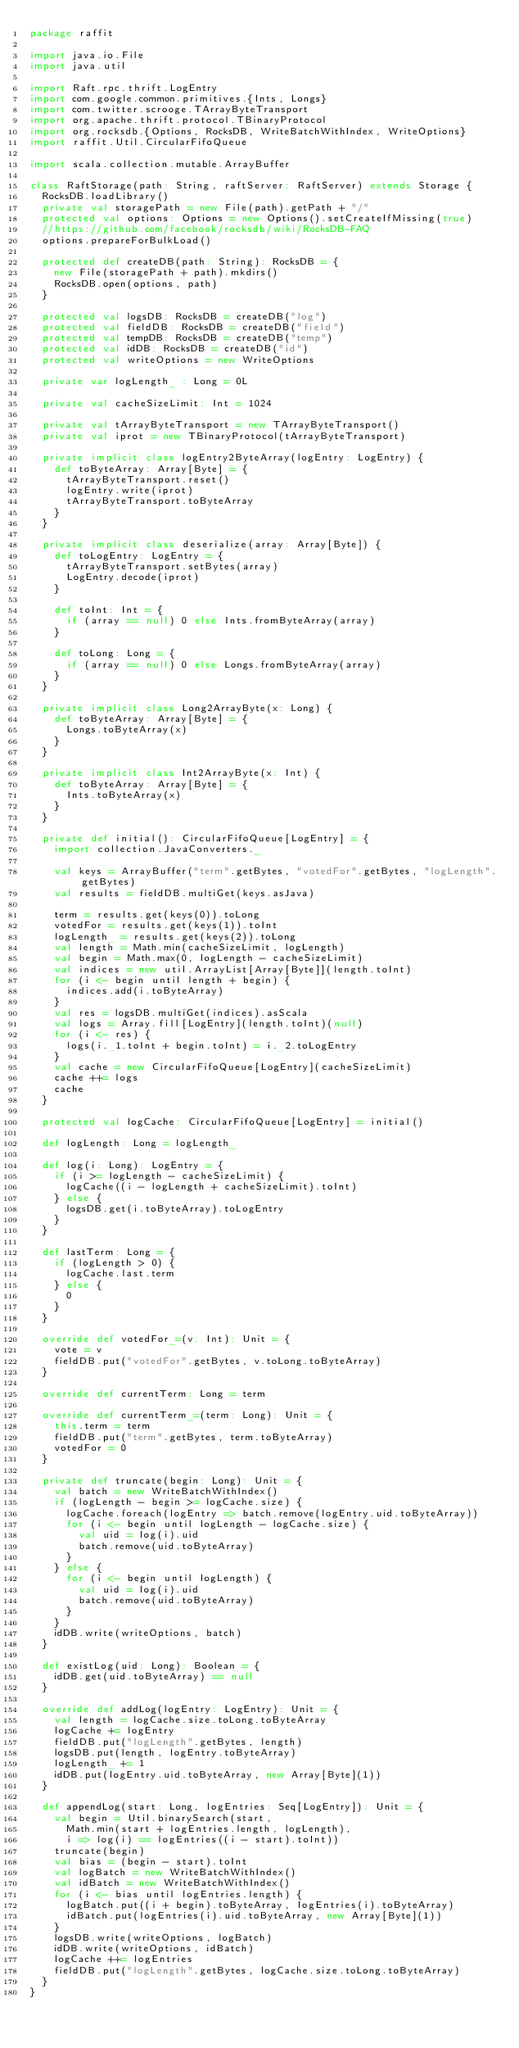Convert code to text. <code><loc_0><loc_0><loc_500><loc_500><_Scala_>package raffit

import java.io.File
import java.util

import Raft.rpc.thrift.LogEntry
import com.google.common.primitives.{Ints, Longs}
import com.twitter.scrooge.TArrayByteTransport
import org.apache.thrift.protocol.TBinaryProtocol
import org.rocksdb.{Options, RocksDB, WriteBatchWithIndex, WriteOptions}
import raffit.Util.CircularFifoQueue

import scala.collection.mutable.ArrayBuffer

class RaftStorage(path: String, raftServer: RaftServer) extends Storage {
  RocksDB.loadLibrary()
  private val storagePath = new File(path).getPath + "/"
  protected val options: Options = new Options().setCreateIfMissing(true)
  //https://github.com/facebook/rocksdb/wiki/RocksDB-FAQ
  options.prepareForBulkLoad()

  protected def createDB(path: String): RocksDB = {
    new File(storagePath + path).mkdirs()
    RocksDB.open(options, path)
  }

  protected val logsDB: RocksDB = createDB("log")
  protected val fieldDB: RocksDB = createDB("field")
  protected val tempDB: RocksDB = createDB("temp")
  protected val idDB: RocksDB = createDB("id")
  protected val writeOptions = new WriteOptions

  private var logLength_ : Long = 0L

  private val cacheSizeLimit: Int = 1024

  private val tArrayByteTransport = new TArrayByteTransport()
  private val iprot = new TBinaryProtocol(tArrayByteTransport)

  private implicit class logEntry2ByteArray(logEntry: LogEntry) {
    def toByteArray: Array[Byte] = {
      tArrayByteTransport.reset()
      logEntry.write(iprot)
      tArrayByteTransport.toByteArray
    }
  }

  private implicit class deserialize(array: Array[Byte]) {
    def toLogEntry: LogEntry = {
      tArrayByteTransport.setBytes(array)
      LogEntry.decode(iprot)
    }

    def toInt: Int = {
      if (array == null) 0 else Ints.fromByteArray(array)
    }

    def toLong: Long = {
      if (array == null) 0 else Longs.fromByteArray(array)
    }
  }

  private implicit class Long2ArrayByte(x: Long) {
    def toByteArray: Array[Byte] = {
      Longs.toByteArray(x)
    }
  }

  private implicit class Int2ArrayByte(x: Int) {
    def toByteArray: Array[Byte] = {
      Ints.toByteArray(x)
    }
  }

  private def initial(): CircularFifoQueue[LogEntry] = {
    import collection.JavaConverters._

    val keys = ArrayBuffer("term".getBytes, "votedFor".getBytes, "logLength".getBytes)
    val results = fieldDB.multiGet(keys.asJava)

    term = results.get(keys(0)).toLong
    votedFor = results.get(keys(1)).toInt
    logLength_ = results.get(keys(2)).toLong
    val length = Math.min(cacheSizeLimit, logLength)
    val begin = Math.max(0, logLength - cacheSizeLimit)
    val indices = new util.ArrayList[Array[Byte]](length.toInt)
    for (i <- begin until length + begin) {
      indices.add(i.toByteArray)
    }
    val res = logsDB.multiGet(indices).asScala
    val logs = Array.fill[LogEntry](length.toInt)(null)
    for (i <- res) {
      logs(i._1.toInt + begin.toInt) = i._2.toLogEntry
    }
    val cache = new CircularFifoQueue[LogEntry](cacheSizeLimit)
    cache ++= logs
    cache
  }

  protected val logCache: CircularFifoQueue[LogEntry] = initial()

  def logLength: Long = logLength_

  def log(i: Long): LogEntry = {
    if (i >= logLength - cacheSizeLimit) {
      logCache((i - logLength + cacheSizeLimit).toInt)
    } else {
      logsDB.get(i.toByteArray).toLogEntry
    }
  }

  def lastTerm: Long = {
    if (logLength > 0) {
      logCache.last.term
    } else {
      0
    }
  }

  override def votedFor_=(v: Int): Unit = {
    vote = v
    fieldDB.put("votedFor".getBytes, v.toLong.toByteArray)
  }

  override def currentTerm: Long = term

  override def currentTerm_=(term: Long): Unit = {
    this.term = term
    fieldDB.put("term".getBytes, term.toByteArray)
    votedFor = 0
  }

  private def truncate(begin: Long): Unit = {
    val batch = new WriteBatchWithIndex()
    if (logLength - begin >= logCache.size) {
      logCache.foreach(logEntry => batch.remove(logEntry.uid.toByteArray))
      for (i <- begin until logLength - logCache.size) {
        val uid = log(i).uid
        batch.remove(uid.toByteArray)
      }
    } else {
      for (i <- begin until logLength) {
        val uid = log(i).uid
        batch.remove(uid.toByteArray)
      }
    }
    idDB.write(writeOptions, batch)
  }

  def existLog(uid: Long): Boolean = {
    idDB.get(uid.toByteArray) == null
  }

  override def addLog(logEntry: LogEntry): Unit = {
    val length = logCache.size.toLong.toByteArray
    logCache += logEntry
    fieldDB.put("logLength".getBytes, length)
    logsDB.put(length, logEntry.toByteArray)
    logLength_ += 1
    idDB.put(logEntry.uid.toByteArray, new Array[Byte](1))
  }

  def appendLog(start: Long, logEntries: Seq[LogEntry]): Unit = {
    val begin = Util.binarySearch(start,
      Math.min(start + logEntries.length, logLength),
      i => log(i) == logEntries((i - start).toInt))
    truncate(begin)
    val bias = (begin - start).toInt
    val logBatch = new WriteBatchWithIndex()
    val idBatch = new WriteBatchWithIndex()
    for (i <- bias until logEntries.length) {
      logBatch.put((i + begin).toByteArray, logEntries(i).toByteArray)
      idBatch.put(logEntries(i).uid.toByteArray, new Array[Byte](1))
    }
    logsDB.write(writeOptions, logBatch)
    idDB.write(writeOptions, idBatch)
    logCache ++= logEntries
    fieldDB.put("logLength".getBytes, logCache.size.toLong.toByteArray)
  }
}
</code> 